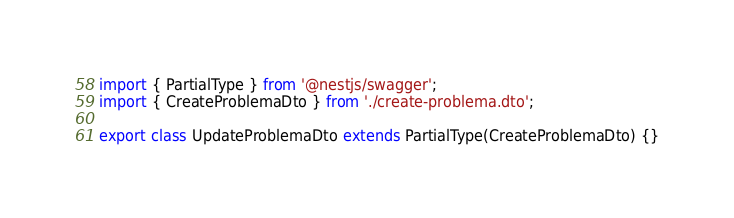Convert code to text. <code><loc_0><loc_0><loc_500><loc_500><_TypeScript_>import { PartialType } from '@nestjs/swagger';
import { CreateProblemaDto } from './create-problema.dto';

export class UpdateProblemaDto extends PartialType(CreateProblemaDto) {}
</code> 